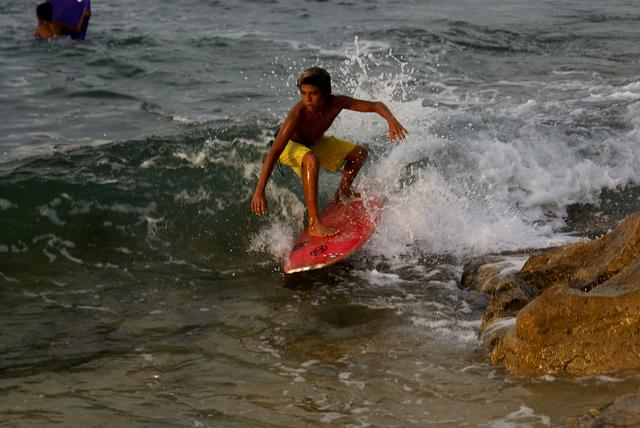What is the most obvious danger here? Please explain your reasoning. rock collision. There are many stone, craggy parts there. 